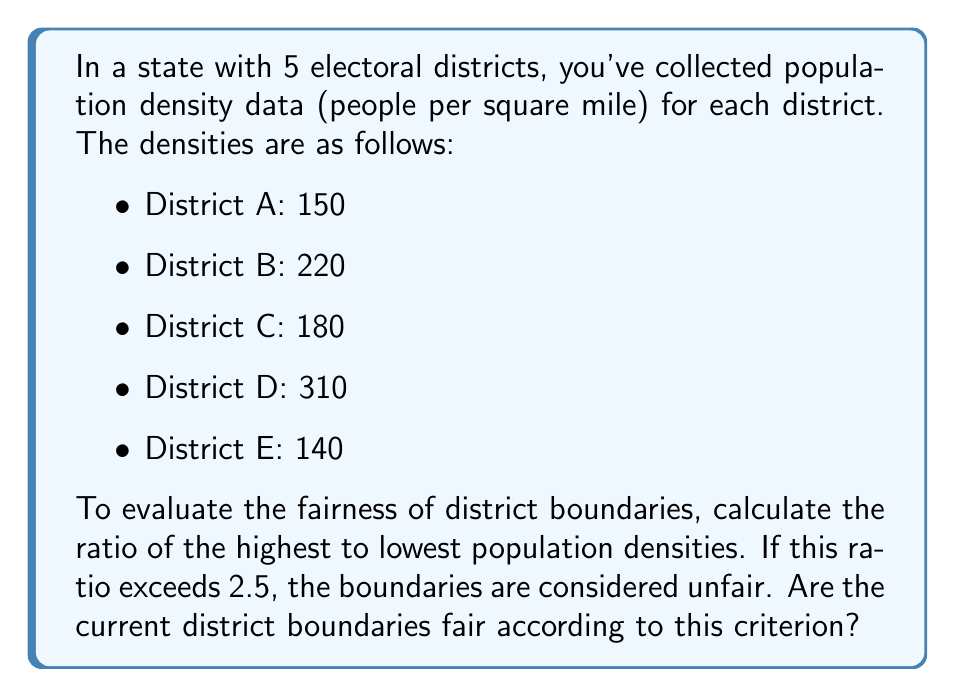Show me your answer to this math problem. To determine if the district boundaries are fair, we need to follow these steps:

1. Identify the highest and lowest population densities:
   Highest: District D with 310 people/sq mile
   Lowest: District E with 140 people/sq mile

2. Calculate the ratio of highest to lowest density:
   $$\text{Ratio} = \frac{\text{Highest density}}{\text{Lowest density}} = \frac{310}{140}$$

3. Simplify the fraction:
   $$\frac{310}{140} = \frac{31}{14} \approx 2.2143$$

4. Compare the ratio to the fairness threshold:
   The calculated ratio (2.2143) is less than the unfairness threshold (2.5).

5. Conclusion:
   Since 2.2143 < 2.5, the current district boundaries are considered fair according to the given criterion.
Answer: Fair (ratio $\approx 2.2143 < 2.5$) 